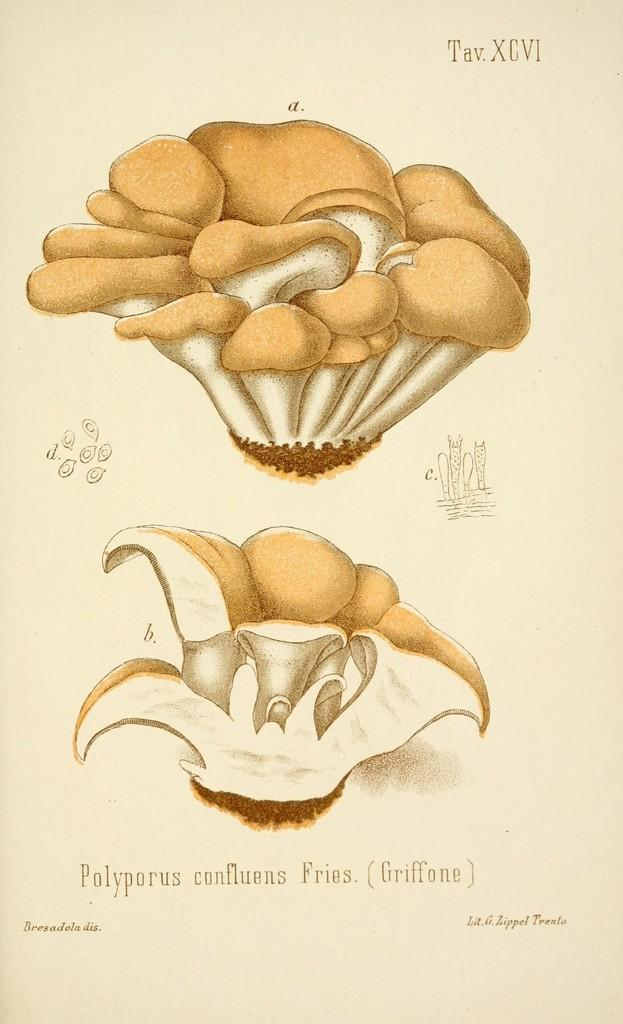What is the main object in the image? There is a paper in the image. What can be found on the paper? The paper contains photos and words. How many fish are swimming in the bucket in the image? There are no fish or buckets present in the image; it only contains a paper with photos and words. 